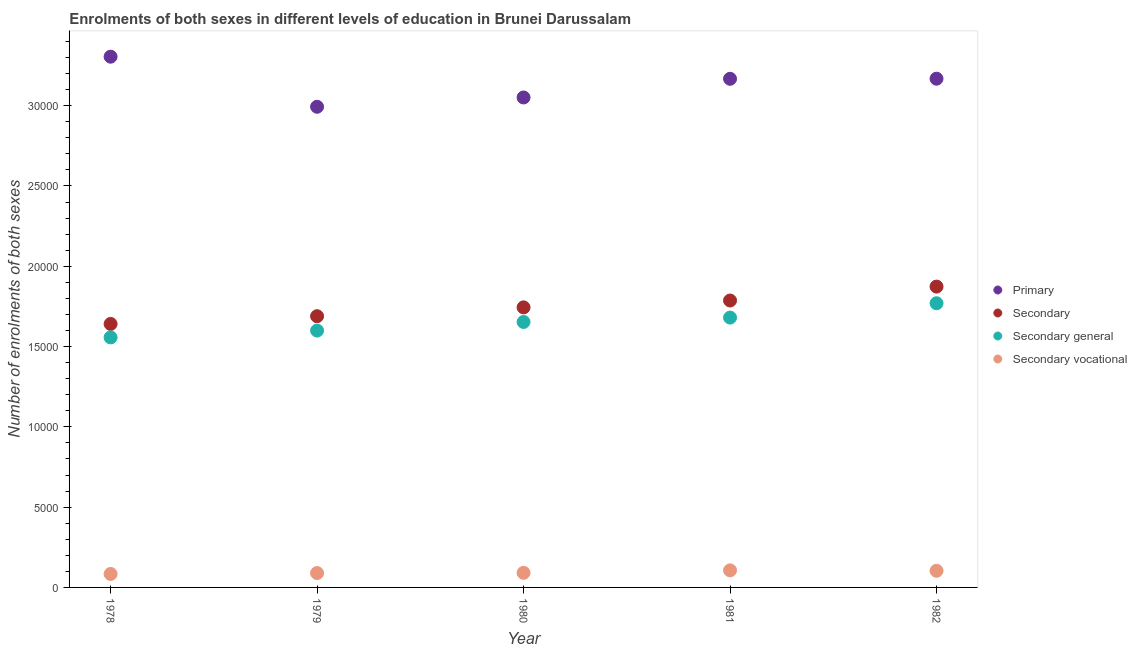What is the number of enrolments in secondary vocational education in 1981?
Your answer should be very brief. 1064. Across all years, what is the maximum number of enrolments in secondary vocational education?
Your answer should be very brief. 1064. Across all years, what is the minimum number of enrolments in secondary general education?
Your answer should be compact. 1.56e+04. In which year was the number of enrolments in primary education maximum?
Keep it short and to the point. 1978. In which year was the number of enrolments in primary education minimum?
Provide a succinct answer. 1979. What is the total number of enrolments in primary education in the graph?
Give a very brief answer. 1.57e+05. What is the difference between the number of enrolments in primary education in 1981 and that in 1982?
Provide a short and direct response. -5. What is the difference between the number of enrolments in secondary education in 1979 and the number of enrolments in secondary general education in 1981?
Ensure brevity in your answer.  86. What is the average number of enrolments in primary education per year?
Offer a very short reply. 3.14e+04. In the year 1979, what is the difference between the number of enrolments in secondary general education and number of enrolments in secondary education?
Offer a terse response. -895. What is the ratio of the number of enrolments in primary education in 1979 to that in 1981?
Ensure brevity in your answer.  0.94. Is the number of enrolments in primary education in 1978 less than that in 1982?
Give a very brief answer. No. What is the difference between the highest and the second highest number of enrolments in secondary education?
Ensure brevity in your answer.  865. What is the difference between the highest and the lowest number of enrolments in secondary education?
Provide a succinct answer. 2324. In how many years, is the number of enrolments in primary education greater than the average number of enrolments in primary education taken over all years?
Your answer should be compact. 3. Is it the case that in every year, the sum of the number of enrolments in secondary general education and number of enrolments in primary education is greater than the sum of number of enrolments in secondary education and number of enrolments in secondary vocational education?
Give a very brief answer. Yes. How many dotlines are there?
Ensure brevity in your answer.  4. What is the difference between two consecutive major ticks on the Y-axis?
Provide a short and direct response. 5000. Are the values on the major ticks of Y-axis written in scientific E-notation?
Give a very brief answer. No. Does the graph contain any zero values?
Ensure brevity in your answer.  No. Does the graph contain grids?
Keep it short and to the point. No. Where does the legend appear in the graph?
Make the answer very short. Center right. How are the legend labels stacked?
Your response must be concise. Vertical. What is the title of the graph?
Your answer should be very brief. Enrolments of both sexes in different levels of education in Brunei Darussalam. Does "First 20% of population" appear as one of the legend labels in the graph?
Provide a short and direct response. No. What is the label or title of the X-axis?
Provide a short and direct response. Year. What is the label or title of the Y-axis?
Make the answer very short. Number of enrolments of both sexes. What is the Number of enrolments of both sexes in Primary in 1978?
Give a very brief answer. 3.31e+04. What is the Number of enrolments of both sexes in Secondary in 1978?
Keep it short and to the point. 1.64e+04. What is the Number of enrolments of both sexes in Secondary general in 1978?
Offer a terse response. 1.56e+04. What is the Number of enrolments of both sexes of Secondary vocational in 1978?
Make the answer very short. 839. What is the Number of enrolments of both sexes in Primary in 1979?
Your response must be concise. 2.99e+04. What is the Number of enrolments of both sexes of Secondary in 1979?
Provide a succinct answer. 1.69e+04. What is the Number of enrolments of both sexes in Secondary general in 1979?
Keep it short and to the point. 1.60e+04. What is the Number of enrolments of both sexes of Secondary vocational in 1979?
Your answer should be very brief. 895. What is the Number of enrolments of both sexes of Primary in 1980?
Offer a very short reply. 3.05e+04. What is the Number of enrolments of both sexes in Secondary in 1980?
Provide a succinct answer. 1.74e+04. What is the Number of enrolments of both sexes in Secondary general in 1980?
Your answer should be compact. 1.65e+04. What is the Number of enrolments of both sexes in Secondary vocational in 1980?
Keep it short and to the point. 909. What is the Number of enrolments of both sexes in Primary in 1981?
Provide a short and direct response. 3.17e+04. What is the Number of enrolments of both sexes in Secondary in 1981?
Your response must be concise. 1.79e+04. What is the Number of enrolments of both sexes in Secondary general in 1981?
Your response must be concise. 1.68e+04. What is the Number of enrolments of both sexes in Secondary vocational in 1981?
Provide a short and direct response. 1064. What is the Number of enrolments of both sexes of Primary in 1982?
Make the answer very short. 3.17e+04. What is the Number of enrolments of both sexes in Secondary in 1982?
Give a very brief answer. 1.87e+04. What is the Number of enrolments of both sexes of Secondary general in 1982?
Offer a terse response. 1.77e+04. What is the Number of enrolments of both sexes in Secondary vocational in 1982?
Make the answer very short. 1036. Across all years, what is the maximum Number of enrolments of both sexes in Primary?
Your response must be concise. 3.31e+04. Across all years, what is the maximum Number of enrolments of both sexes of Secondary?
Offer a very short reply. 1.87e+04. Across all years, what is the maximum Number of enrolments of both sexes of Secondary general?
Provide a succinct answer. 1.77e+04. Across all years, what is the maximum Number of enrolments of both sexes in Secondary vocational?
Offer a terse response. 1064. Across all years, what is the minimum Number of enrolments of both sexes of Primary?
Keep it short and to the point. 2.99e+04. Across all years, what is the minimum Number of enrolments of both sexes of Secondary?
Provide a short and direct response. 1.64e+04. Across all years, what is the minimum Number of enrolments of both sexes of Secondary general?
Ensure brevity in your answer.  1.56e+04. Across all years, what is the minimum Number of enrolments of both sexes of Secondary vocational?
Make the answer very short. 839. What is the total Number of enrolments of both sexes in Primary in the graph?
Offer a very short reply. 1.57e+05. What is the total Number of enrolments of both sexes in Secondary in the graph?
Keep it short and to the point. 8.73e+04. What is the total Number of enrolments of both sexes in Secondary general in the graph?
Offer a very short reply. 8.26e+04. What is the total Number of enrolments of both sexes in Secondary vocational in the graph?
Make the answer very short. 4743. What is the difference between the Number of enrolments of both sexes in Primary in 1978 and that in 1979?
Your answer should be very brief. 3119. What is the difference between the Number of enrolments of both sexes of Secondary in 1978 and that in 1979?
Offer a very short reply. -481. What is the difference between the Number of enrolments of both sexes in Secondary general in 1978 and that in 1979?
Provide a succinct answer. -425. What is the difference between the Number of enrolments of both sexes of Secondary vocational in 1978 and that in 1979?
Provide a short and direct response. -56. What is the difference between the Number of enrolments of both sexes in Primary in 1978 and that in 1980?
Ensure brevity in your answer.  2540. What is the difference between the Number of enrolments of both sexes of Secondary in 1978 and that in 1980?
Ensure brevity in your answer.  -1031. What is the difference between the Number of enrolments of both sexes of Secondary general in 1978 and that in 1980?
Make the answer very short. -961. What is the difference between the Number of enrolments of both sexes in Secondary vocational in 1978 and that in 1980?
Offer a very short reply. -70. What is the difference between the Number of enrolments of both sexes in Primary in 1978 and that in 1981?
Provide a succinct answer. 1376. What is the difference between the Number of enrolments of both sexes in Secondary in 1978 and that in 1981?
Make the answer very short. -1459. What is the difference between the Number of enrolments of both sexes of Secondary general in 1978 and that in 1981?
Make the answer very short. -1234. What is the difference between the Number of enrolments of both sexes of Secondary vocational in 1978 and that in 1981?
Your answer should be compact. -225. What is the difference between the Number of enrolments of both sexes in Primary in 1978 and that in 1982?
Offer a very short reply. 1371. What is the difference between the Number of enrolments of both sexes of Secondary in 1978 and that in 1982?
Provide a short and direct response. -2324. What is the difference between the Number of enrolments of both sexes of Secondary general in 1978 and that in 1982?
Provide a short and direct response. -2127. What is the difference between the Number of enrolments of both sexes of Secondary vocational in 1978 and that in 1982?
Give a very brief answer. -197. What is the difference between the Number of enrolments of both sexes in Primary in 1979 and that in 1980?
Make the answer very short. -579. What is the difference between the Number of enrolments of both sexes of Secondary in 1979 and that in 1980?
Ensure brevity in your answer.  -550. What is the difference between the Number of enrolments of both sexes of Secondary general in 1979 and that in 1980?
Your answer should be very brief. -536. What is the difference between the Number of enrolments of both sexes in Secondary vocational in 1979 and that in 1980?
Provide a succinct answer. -14. What is the difference between the Number of enrolments of both sexes of Primary in 1979 and that in 1981?
Your answer should be compact. -1743. What is the difference between the Number of enrolments of both sexes in Secondary in 1979 and that in 1981?
Provide a succinct answer. -978. What is the difference between the Number of enrolments of both sexes in Secondary general in 1979 and that in 1981?
Provide a succinct answer. -809. What is the difference between the Number of enrolments of both sexes of Secondary vocational in 1979 and that in 1981?
Offer a very short reply. -169. What is the difference between the Number of enrolments of both sexes in Primary in 1979 and that in 1982?
Keep it short and to the point. -1748. What is the difference between the Number of enrolments of both sexes in Secondary in 1979 and that in 1982?
Offer a terse response. -1843. What is the difference between the Number of enrolments of both sexes of Secondary general in 1979 and that in 1982?
Provide a succinct answer. -1702. What is the difference between the Number of enrolments of both sexes of Secondary vocational in 1979 and that in 1982?
Keep it short and to the point. -141. What is the difference between the Number of enrolments of both sexes of Primary in 1980 and that in 1981?
Keep it short and to the point. -1164. What is the difference between the Number of enrolments of both sexes of Secondary in 1980 and that in 1981?
Your response must be concise. -428. What is the difference between the Number of enrolments of both sexes in Secondary general in 1980 and that in 1981?
Offer a very short reply. -273. What is the difference between the Number of enrolments of both sexes in Secondary vocational in 1980 and that in 1981?
Keep it short and to the point. -155. What is the difference between the Number of enrolments of both sexes in Primary in 1980 and that in 1982?
Ensure brevity in your answer.  -1169. What is the difference between the Number of enrolments of both sexes in Secondary in 1980 and that in 1982?
Your answer should be very brief. -1293. What is the difference between the Number of enrolments of both sexes of Secondary general in 1980 and that in 1982?
Offer a very short reply. -1166. What is the difference between the Number of enrolments of both sexes in Secondary vocational in 1980 and that in 1982?
Provide a short and direct response. -127. What is the difference between the Number of enrolments of both sexes of Primary in 1981 and that in 1982?
Keep it short and to the point. -5. What is the difference between the Number of enrolments of both sexes of Secondary in 1981 and that in 1982?
Your answer should be very brief. -865. What is the difference between the Number of enrolments of both sexes of Secondary general in 1981 and that in 1982?
Offer a terse response. -893. What is the difference between the Number of enrolments of both sexes in Secondary vocational in 1981 and that in 1982?
Offer a terse response. 28. What is the difference between the Number of enrolments of both sexes in Primary in 1978 and the Number of enrolments of both sexes in Secondary in 1979?
Offer a very short reply. 1.62e+04. What is the difference between the Number of enrolments of both sexes of Primary in 1978 and the Number of enrolments of both sexes of Secondary general in 1979?
Give a very brief answer. 1.71e+04. What is the difference between the Number of enrolments of both sexes of Primary in 1978 and the Number of enrolments of both sexes of Secondary vocational in 1979?
Give a very brief answer. 3.22e+04. What is the difference between the Number of enrolments of both sexes in Secondary in 1978 and the Number of enrolments of both sexes in Secondary general in 1979?
Ensure brevity in your answer.  414. What is the difference between the Number of enrolments of both sexes in Secondary in 1978 and the Number of enrolments of both sexes in Secondary vocational in 1979?
Provide a short and direct response. 1.55e+04. What is the difference between the Number of enrolments of both sexes in Secondary general in 1978 and the Number of enrolments of both sexes in Secondary vocational in 1979?
Provide a succinct answer. 1.47e+04. What is the difference between the Number of enrolments of both sexes of Primary in 1978 and the Number of enrolments of both sexes of Secondary in 1980?
Give a very brief answer. 1.56e+04. What is the difference between the Number of enrolments of both sexes of Primary in 1978 and the Number of enrolments of both sexes of Secondary general in 1980?
Keep it short and to the point. 1.65e+04. What is the difference between the Number of enrolments of both sexes in Primary in 1978 and the Number of enrolments of both sexes in Secondary vocational in 1980?
Offer a very short reply. 3.21e+04. What is the difference between the Number of enrolments of both sexes of Secondary in 1978 and the Number of enrolments of both sexes of Secondary general in 1980?
Provide a short and direct response. -122. What is the difference between the Number of enrolments of both sexes in Secondary in 1978 and the Number of enrolments of both sexes in Secondary vocational in 1980?
Offer a terse response. 1.55e+04. What is the difference between the Number of enrolments of both sexes in Secondary general in 1978 and the Number of enrolments of both sexes in Secondary vocational in 1980?
Provide a succinct answer. 1.47e+04. What is the difference between the Number of enrolments of both sexes in Primary in 1978 and the Number of enrolments of both sexes in Secondary in 1981?
Offer a very short reply. 1.52e+04. What is the difference between the Number of enrolments of both sexes of Primary in 1978 and the Number of enrolments of both sexes of Secondary general in 1981?
Ensure brevity in your answer.  1.62e+04. What is the difference between the Number of enrolments of both sexes in Primary in 1978 and the Number of enrolments of both sexes in Secondary vocational in 1981?
Give a very brief answer. 3.20e+04. What is the difference between the Number of enrolments of both sexes in Secondary in 1978 and the Number of enrolments of both sexes in Secondary general in 1981?
Make the answer very short. -395. What is the difference between the Number of enrolments of both sexes of Secondary in 1978 and the Number of enrolments of both sexes of Secondary vocational in 1981?
Your answer should be very brief. 1.53e+04. What is the difference between the Number of enrolments of both sexes in Secondary general in 1978 and the Number of enrolments of both sexes in Secondary vocational in 1981?
Give a very brief answer. 1.45e+04. What is the difference between the Number of enrolments of both sexes in Primary in 1978 and the Number of enrolments of both sexes in Secondary in 1982?
Offer a terse response. 1.43e+04. What is the difference between the Number of enrolments of both sexes in Primary in 1978 and the Number of enrolments of both sexes in Secondary general in 1982?
Ensure brevity in your answer.  1.54e+04. What is the difference between the Number of enrolments of both sexes of Primary in 1978 and the Number of enrolments of both sexes of Secondary vocational in 1982?
Offer a very short reply. 3.20e+04. What is the difference between the Number of enrolments of both sexes of Secondary in 1978 and the Number of enrolments of both sexes of Secondary general in 1982?
Your answer should be compact. -1288. What is the difference between the Number of enrolments of both sexes of Secondary in 1978 and the Number of enrolments of both sexes of Secondary vocational in 1982?
Keep it short and to the point. 1.54e+04. What is the difference between the Number of enrolments of both sexes in Secondary general in 1978 and the Number of enrolments of both sexes in Secondary vocational in 1982?
Offer a terse response. 1.45e+04. What is the difference between the Number of enrolments of both sexes of Primary in 1979 and the Number of enrolments of both sexes of Secondary in 1980?
Keep it short and to the point. 1.25e+04. What is the difference between the Number of enrolments of both sexes in Primary in 1979 and the Number of enrolments of both sexes in Secondary general in 1980?
Provide a short and direct response. 1.34e+04. What is the difference between the Number of enrolments of both sexes in Primary in 1979 and the Number of enrolments of both sexes in Secondary vocational in 1980?
Make the answer very short. 2.90e+04. What is the difference between the Number of enrolments of both sexes of Secondary in 1979 and the Number of enrolments of both sexes of Secondary general in 1980?
Offer a very short reply. 359. What is the difference between the Number of enrolments of both sexes of Secondary in 1979 and the Number of enrolments of both sexes of Secondary vocational in 1980?
Your answer should be compact. 1.60e+04. What is the difference between the Number of enrolments of both sexes of Secondary general in 1979 and the Number of enrolments of both sexes of Secondary vocational in 1980?
Your response must be concise. 1.51e+04. What is the difference between the Number of enrolments of both sexes of Primary in 1979 and the Number of enrolments of both sexes of Secondary in 1981?
Your answer should be compact. 1.21e+04. What is the difference between the Number of enrolments of both sexes in Primary in 1979 and the Number of enrolments of both sexes in Secondary general in 1981?
Give a very brief answer. 1.31e+04. What is the difference between the Number of enrolments of both sexes in Primary in 1979 and the Number of enrolments of both sexes in Secondary vocational in 1981?
Offer a terse response. 2.89e+04. What is the difference between the Number of enrolments of both sexes in Secondary in 1979 and the Number of enrolments of both sexes in Secondary general in 1981?
Your answer should be very brief. 86. What is the difference between the Number of enrolments of both sexes in Secondary in 1979 and the Number of enrolments of both sexes in Secondary vocational in 1981?
Your answer should be very brief. 1.58e+04. What is the difference between the Number of enrolments of both sexes of Secondary general in 1979 and the Number of enrolments of both sexes of Secondary vocational in 1981?
Ensure brevity in your answer.  1.49e+04. What is the difference between the Number of enrolments of both sexes in Primary in 1979 and the Number of enrolments of both sexes in Secondary in 1982?
Make the answer very short. 1.12e+04. What is the difference between the Number of enrolments of both sexes of Primary in 1979 and the Number of enrolments of both sexes of Secondary general in 1982?
Offer a very short reply. 1.22e+04. What is the difference between the Number of enrolments of both sexes of Primary in 1979 and the Number of enrolments of both sexes of Secondary vocational in 1982?
Make the answer very short. 2.89e+04. What is the difference between the Number of enrolments of both sexes of Secondary in 1979 and the Number of enrolments of both sexes of Secondary general in 1982?
Ensure brevity in your answer.  -807. What is the difference between the Number of enrolments of both sexes in Secondary in 1979 and the Number of enrolments of both sexes in Secondary vocational in 1982?
Keep it short and to the point. 1.59e+04. What is the difference between the Number of enrolments of both sexes of Secondary general in 1979 and the Number of enrolments of both sexes of Secondary vocational in 1982?
Your answer should be very brief. 1.50e+04. What is the difference between the Number of enrolments of both sexes in Primary in 1980 and the Number of enrolments of both sexes in Secondary in 1981?
Give a very brief answer. 1.26e+04. What is the difference between the Number of enrolments of both sexes of Primary in 1980 and the Number of enrolments of both sexes of Secondary general in 1981?
Ensure brevity in your answer.  1.37e+04. What is the difference between the Number of enrolments of both sexes of Primary in 1980 and the Number of enrolments of both sexes of Secondary vocational in 1981?
Offer a terse response. 2.94e+04. What is the difference between the Number of enrolments of both sexes of Secondary in 1980 and the Number of enrolments of both sexes of Secondary general in 1981?
Offer a very short reply. 636. What is the difference between the Number of enrolments of both sexes of Secondary in 1980 and the Number of enrolments of both sexes of Secondary vocational in 1981?
Make the answer very short. 1.64e+04. What is the difference between the Number of enrolments of both sexes of Secondary general in 1980 and the Number of enrolments of both sexes of Secondary vocational in 1981?
Offer a terse response. 1.55e+04. What is the difference between the Number of enrolments of both sexes of Primary in 1980 and the Number of enrolments of both sexes of Secondary in 1982?
Offer a very short reply. 1.18e+04. What is the difference between the Number of enrolments of both sexes in Primary in 1980 and the Number of enrolments of both sexes in Secondary general in 1982?
Give a very brief answer. 1.28e+04. What is the difference between the Number of enrolments of both sexes of Primary in 1980 and the Number of enrolments of both sexes of Secondary vocational in 1982?
Provide a succinct answer. 2.95e+04. What is the difference between the Number of enrolments of both sexes in Secondary in 1980 and the Number of enrolments of both sexes in Secondary general in 1982?
Provide a succinct answer. -257. What is the difference between the Number of enrolments of both sexes of Secondary in 1980 and the Number of enrolments of both sexes of Secondary vocational in 1982?
Provide a succinct answer. 1.64e+04. What is the difference between the Number of enrolments of both sexes of Secondary general in 1980 and the Number of enrolments of both sexes of Secondary vocational in 1982?
Provide a succinct answer. 1.55e+04. What is the difference between the Number of enrolments of both sexes in Primary in 1981 and the Number of enrolments of both sexes in Secondary in 1982?
Provide a short and direct response. 1.29e+04. What is the difference between the Number of enrolments of both sexes in Primary in 1981 and the Number of enrolments of both sexes in Secondary general in 1982?
Offer a very short reply. 1.40e+04. What is the difference between the Number of enrolments of both sexes in Primary in 1981 and the Number of enrolments of both sexes in Secondary vocational in 1982?
Your answer should be compact. 3.06e+04. What is the difference between the Number of enrolments of both sexes of Secondary in 1981 and the Number of enrolments of both sexes of Secondary general in 1982?
Your response must be concise. 171. What is the difference between the Number of enrolments of both sexes in Secondary in 1981 and the Number of enrolments of both sexes in Secondary vocational in 1982?
Provide a short and direct response. 1.68e+04. What is the difference between the Number of enrolments of both sexes of Secondary general in 1981 and the Number of enrolments of both sexes of Secondary vocational in 1982?
Your answer should be compact. 1.58e+04. What is the average Number of enrolments of both sexes of Primary per year?
Your answer should be very brief. 3.14e+04. What is the average Number of enrolments of both sexes in Secondary per year?
Keep it short and to the point. 1.75e+04. What is the average Number of enrolments of both sexes in Secondary general per year?
Provide a short and direct response. 1.65e+04. What is the average Number of enrolments of both sexes of Secondary vocational per year?
Your answer should be very brief. 948.6. In the year 1978, what is the difference between the Number of enrolments of both sexes of Primary and Number of enrolments of both sexes of Secondary?
Your response must be concise. 1.66e+04. In the year 1978, what is the difference between the Number of enrolments of both sexes in Primary and Number of enrolments of both sexes in Secondary general?
Your response must be concise. 1.75e+04. In the year 1978, what is the difference between the Number of enrolments of both sexes of Primary and Number of enrolments of both sexes of Secondary vocational?
Your answer should be very brief. 3.22e+04. In the year 1978, what is the difference between the Number of enrolments of both sexes of Secondary and Number of enrolments of both sexes of Secondary general?
Your answer should be compact. 839. In the year 1978, what is the difference between the Number of enrolments of both sexes in Secondary and Number of enrolments of both sexes in Secondary vocational?
Offer a very short reply. 1.56e+04. In the year 1978, what is the difference between the Number of enrolments of both sexes in Secondary general and Number of enrolments of both sexes in Secondary vocational?
Your response must be concise. 1.47e+04. In the year 1979, what is the difference between the Number of enrolments of both sexes of Primary and Number of enrolments of both sexes of Secondary?
Provide a succinct answer. 1.30e+04. In the year 1979, what is the difference between the Number of enrolments of both sexes of Primary and Number of enrolments of both sexes of Secondary general?
Give a very brief answer. 1.39e+04. In the year 1979, what is the difference between the Number of enrolments of both sexes of Primary and Number of enrolments of both sexes of Secondary vocational?
Your answer should be very brief. 2.90e+04. In the year 1979, what is the difference between the Number of enrolments of both sexes of Secondary and Number of enrolments of both sexes of Secondary general?
Offer a terse response. 895. In the year 1979, what is the difference between the Number of enrolments of both sexes in Secondary and Number of enrolments of both sexes in Secondary vocational?
Make the answer very short. 1.60e+04. In the year 1979, what is the difference between the Number of enrolments of both sexes of Secondary general and Number of enrolments of both sexes of Secondary vocational?
Your answer should be compact. 1.51e+04. In the year 1980, what is the difference between the Number of enrolments of both sexes in Primary and Number of enrolments of both sexes in Secondary?
Make the answer very short. 1.31e+04. In the year 1980, what is the difference between the Number of enrolments of both sexes in Primary and Number of enrolments of both sexes in Secondary general?
Your response must be concise. 1.40e+04. In the year 1980, what is the difference between the Number of enrolments of both sexes in Primary and Number of enrolments of both sexes in Secondary vocational?
Keep it short and to the point. 2.96e+04. In the year 1980, what is the difference between the Number of enrolments of both sexes in Secondary and Number of enrolments of both sexes in Secondary general?
Keep it short and to the point. 909. In the year 1980, what is the difference between the Number of enrolments of both sexes of Secondary and Number of enrolments of both sexes of Secondary vocational?
Ensure brevity in your answer.  1.65e+04. In the year 1980, what is the difference between the Number of enrolments of both sexes of Secondary general and Number of enrolments of both sexes of Secondary vocational?
Ensure brevity in your answer.  1.56e+04. In the year 1981, what is the difference between the Number of enrolments of both sexes in Primary and Number of enrolments of both sexes in Secondary?
Ensure brevity in your answer.  1.38e+04. In the year 1981, what is the difference between the Number of enrolments of both sexes in Primary and Number of enrolments of both sexes in Secondary general?
Keep it short and to the point. 1.49e+04. In the year 1981, what is the difference between the Number of enrolments of both sexes of Primary and Number of enrolments of both sexes of Secondary vocational?
Make the answer very short. 3.06e+04. In the year 1981, what is the difference between the Number of enrolments of both sexes of Secondary and Number of enrolments of both sexes of Secondary general?
Provide a succinct answer. 1064. In the year 1981, what is the difference between the Number of enrolments of both sexes in Secondary and Number of enrolments of both sexes in Secondary vocational?
Your answer should be very brief. 1.68e+04. In the year 1981, what is the difference between the Number of enrolments of both sexes in Secondary general and Number of enrolments of both sexes in Secondary vocational?
Your answer should be compact. 1.57e+04. In the year 1982, what is the difference between the Number of enrolments of both sexes of Primary and Number of enrolments of both sexes of Secondary?
Offer a terse response. 1.29e+04. In the year 1982, what is the difference between the Number of enrolments of both sexes of Primary and Number of enrolments of both sexes of Secondary general?
Ensure brevity in your answer.  1.40e+04. In the year 1982, what is the difference between the Number of enrolments of both sexes in Primary and Number of enrolments of both sexes in Secondary vocational?
Ensure brevity in your answer.  3.06e+04. In the year 1982, what is the difference between the Number of enrolments of both sexes in Secondary and Number of enrolments of both sexes in Secondary general?
Your response must be concise. 1036. In the year 1982, what is the difference between the Number of enrolments of both sexes in Secondary and Number of enrolments of both sexes in Secondary vocational?
Give a very brief answer. 1.77e+04. In the year 1982, what is the difference between the Number of enrolments of both sexes in Secondary general and Number of enrolments of both sexes in Secondary vocational?
Your answer should be compact. 1.67e+04. What is the ratio of the Number of enrolments of both sexes of Primary in 1978 to that in 1979?
Keep it short and to the point. 1.1. What is the ratio of the Number of enrolments of both sexes in Secondary in 1978 to that in 1979?
Keep it short and to the point. 0.97. What is the ratio of the Number of enrolments of both sexes in Secondary general in 1978 to that in 1979?
Provide a succinct answer. 0.97. What is the ratio of the Number of enrolments of both sexes of Secondary vocational in 1978 to that in 1979?
Make the answer very short. 0.94. What is the ratio of the Number of enrolments of both sexes of Primary in 1978 to that in 1980?
Your answer should be compact. 1.08. What is the ratio of the Number of enrolments of both sexes in Secondary in 1978 to that in 1980?
Provide a short and direct response. 0.94. What is the ratio of the Number of enrolments of both sexes of Secondary general in 1978 to that in 1980?
Keep it short and to the point. 0.94. What is the ratio of the Number of enrolments of both sexes of Secondary vocational in 1978 to that in 1980?
Provide a succinct answer. 0.92. What is the ratio of the Number of enrolments of both sexes in Primary in 1978 to that in 1981?
Make the answer very short. 1.04. What is the ratio of the Number of enrolments of both sexes of Secondary in 1978 to that in 1981?
Offer a very short reply. 0.92. What is the ratio of the Number of enrolments of both sexes of Secondary general in 1978 to that in 1981?
Offer a very short reply. 0.93. What is the ratio of the Number of enrolments of both sexes in Secondary vocational in 1978 to that in 1981?
Your answer should be compact. 0.79. What is the ratio of the Number of enrolments of both sexes in Primary in 1978 to that in 1982?
Offer a terse response. 1.04. What is the ratio of the Number of enrolments of both sexes in Secondary in 1978 to that in 1982?
Provide a short and direct response. 0.88. What is the ratio of the Number of enrolments of both sexes of Secondary general in 1978 to that in 1982?
Ensure brevity in your answer.  0.88. What is the ratio of the Number of enrolments of both sexes in Secondary vocational in 1978 to that in 1982?
Keep it short and to the point. 0.81. What is the ratio of the Number of enrolments of both sexes of Primary in 1979 to that in 1980?
Give a very brief answer. 0.98. What is the ratio of the Number of enrolments of both sexes of Secondary in 1979 to that in 1980?
Offer a terse response. 0.97. What is the ratio of the Number of enrolments of both sexes of Secondary general in 1979 to that in 1980?
Offer a terse response. 0.97. What is the ratio of the Number of enrolments of both sexes in Secondary vocational in 1979 to that in 1980?
Give a very brief answer. 0.98. What is the ratio of the Number of enrolments of both sexes in Primary in 1979 to that in 1981?
Ensure brevity in your answer.  0.94. What is the ratio of the Number of enrolments of both sexes in Secondary in 1979 to that in 1981?
Your response must be concise. 0.95. What is the ratio of the Number of enrolments of both sexes in Secondary general in 1979 to that in 1981?
Ensure brevity in your answer.  0.95. What is the ratio of the Number of enrolments of both sexes in Secondary vocational in 1979 to that in 1981?
Your response must be concise. 0.84. What is the ratio of the Number of enrolments of both sexes in Primary in 1979 to that in 1982?
Your response must be concise. 0.94. What is the ratio of the Number of enrolments of both sexes in Secondary in 1979 to that in 1982?
Offer a terse response. 0.9. What is the ratio of the Number of enrolments of both sexes of Secondary general in 1979 to that in 1982?
Your answer should be compact. 0.9. What is the ratio of the Number of enrolments of both sexes in Secondary vocational in 1979 to that in 1982?
Make the answer very short. 0.86. What is the ratio of the Number of enrolments of both sexes of Primary in 1980 to that in 1981?
Your response must be concise. 0.96. What is the ratio of the Number of enrolments of both sexes in Secondary in 1980 to that in 1981?
Offer a terse response. 0.98. What is the ratio of the Number of enrolments of both sexes in Secondary general in 1980 to that in 1981?
Offer a very short reply. 0.98. What is the ratio of the Number of enrolments of both sexes of Secondary vocational in 1980 to that in 1981?
Offer a terse response. 0.85. What is the ratio of the Number of enrolments of both sexes of Primary in 1980 to that in 1982?
Make the answer very short. 0.96. What is the ratio of the Number of enrolments of both sexes of Secondary in 1980 to that in 1982?
Keep it short and to the point. 0.93. What is the ratio of the Number of enrolments of both sexes of Secondary general in 1980 to that in 1982?
Offer a terse response. 0.93. What is the ratio of the Number of enrolments of both sexes in Secondary vocational in 1980 to that in 1982?
Ensure brevity in your answer.  0.88. What is the ratio of the Number of enrolments of both sexes in Primary in 1981 to that in 1982?
Provide a short and direct response. 1. What is the ratio of the Number of enrolments of both sexes in Secondary in 1981 to that in 1982?
Keep it short and to the point. 0.95. What is the ratio of the Number of enrolments of both sexes in Secondary general in 1981 to that in 1982?
Keep it short and to the point. 0.95. What is the ratio of the Number of enrolments of both sexes in Secondary vocational in 1981 to that in 1982?
Provide a short and direct response. 1.03. What is the difference between the highest and the second highest Number of enrolments of both sexes of Primary?
Provide a succinct answer. 1371. What is the difference between the highest and the second highest Number of enrolments of both sexes in Secondary?
Offer a very short reply. 865. What is the difference between the highest and the second highest Number of enrolments of both sexes in Secondary general?
Your response must be concise. 893. What is the difference between the highest and the lowest Number of enrolments of both sexes of Primary?
Make the answer very short. 3119. What is the difference between the highest and the lowest Number of enrolments of both sexes in Secondary?
Give a very brief answer. 2324. What is the difference between the highest and the lowest Number of enrolments of both sexes in Secondary general?
Your response must be concise. 2127. What is the difference between the highest and the lowest Number of enrolments of both sexes of Secondary vocational?
Offer a terse response. 225. 